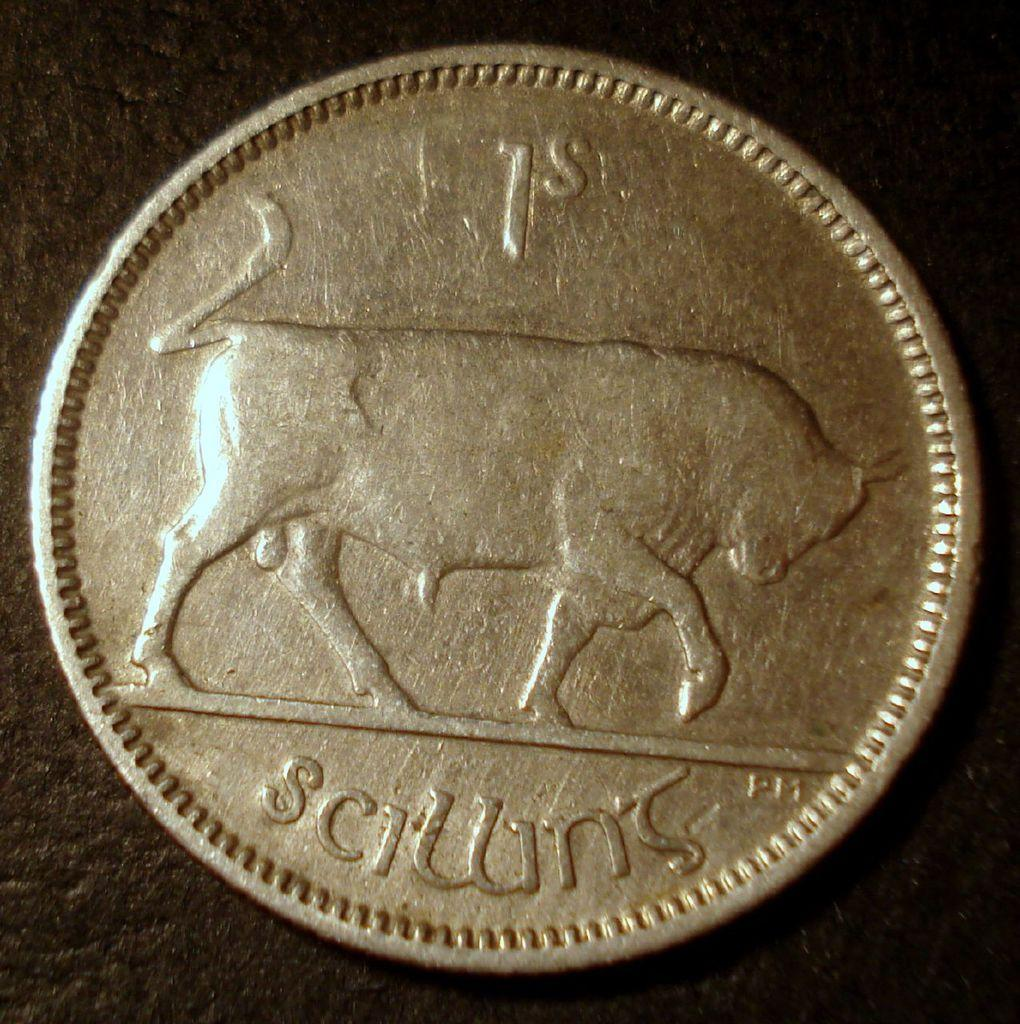Provide a one-sentence caption for the provided image. gold coin with picture of bull and words 1st scillins. 